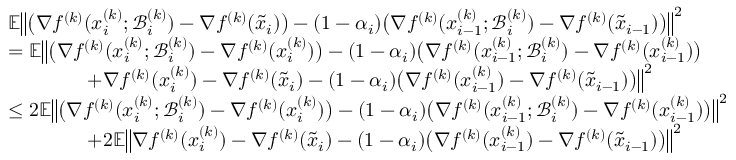Convert formula to latex. <formula><loc_0><loc_0><loc_500><loc_500>\begin{array} { r l } & { \mathbb { E } \left \| \left ( \nabla f ^ { ( k ) } ( x _ { i } ^ { ( k ) } ; \mathcal { B } _ { i } ^ { ( k ) } ) - \nabla f ^ { ( k ) } ( \tilde { x } _ { i } ) \right ) - ( 1 - \alpha _ { i } ) \left ( \nabla f ^ { ( k ) } ( x _ { i - 1 } ^ { ( k ) } ; \mathcal { B } _ { i } ^ { ( k ) } ) - \nabla f ^ { ( k ) } ( \tilde { x } _ { i - 1 } ) \right ) \right \| ^ { 2 } } \\ & { = \mathbb { E } \left \| \left ( \nabla f ^ { ( k ) } ( x _ { i } ^ { ( k ) } ; \mathcal { B } _ { i } ^ { ( k ) } ) - \nabla f ^ { ( k ) } ( x _ { i } ^ { ( k ) } ) \right ) - ( 1 - \alpha _ { i } ) \left ( \nabla f ^ { ( k ) } ( x _ { i - 1 } ^ { ( k ) } ; \mathcal { B } _ { i } ^ { ( k ) } ) - \nabla f ^ { ( k ) } ( x _ { i - 1 } ^ { ( k ) } ) \right ) } \\ & { \quad + \nabla f ^ { ( k ) } ( x _ { i } ^ { ( k ) } ) - \nabla f ^ { ( k ) } ( \tilde { x } _ { i } ) - ( 1 - \alpha _ { i } ) \left ( \nabla f ^ { ( k ) } ( x _ { i - 1 } ^ { ( k ) } ) - \nabla f ^ { ( k ) } ( \tilde { x } _ { i - 1 } ) \right ) \right \| ^ { 2 } } \\ & { \leq 2 \mathbb { E } \left \| \left ( \nabla f ^ { ( k ) } ( x _ { i } ^ { ( k ) } ; \mathcal { B } _ { i } ^ { ( k ) } ) - \nabla f ^ { ( k ) } ( x _ { i } ^ { ( k ) } ) \right ) - ( 1 - \alpha _ { i } ) \left ( \nabla f ^ { ( k ) } ( x _ { i - 1 } ^ { ( k ) } ; \mathcal { B } _ { i } ^ { ( k ) } ) - \nabla f ^ { ( k ) } ( x _ { i - 1 } ^ { ( k ) } ) \right ) \right \| ^ { 2 } } \\ & { \quad + 2 \mathbb { E } \left \| \nabla f ^ { ( k ) } ( x _ { i } ^ { ( k ) } ) - \nabla f ^ { ( k ) } ( \tilde { x } _ { i } ) - ( 1 - \alpha _ { i } ) \left ( \nabla f ^ { ( k ) } ( x _ { i - 1 } ^ { ( k ) } ) - \nabla f ^ { ( k ) } ( \tilde { x } _ { i - 1 } ) \right ) \right \| ^ { 2 } } \end{array}</formula> 